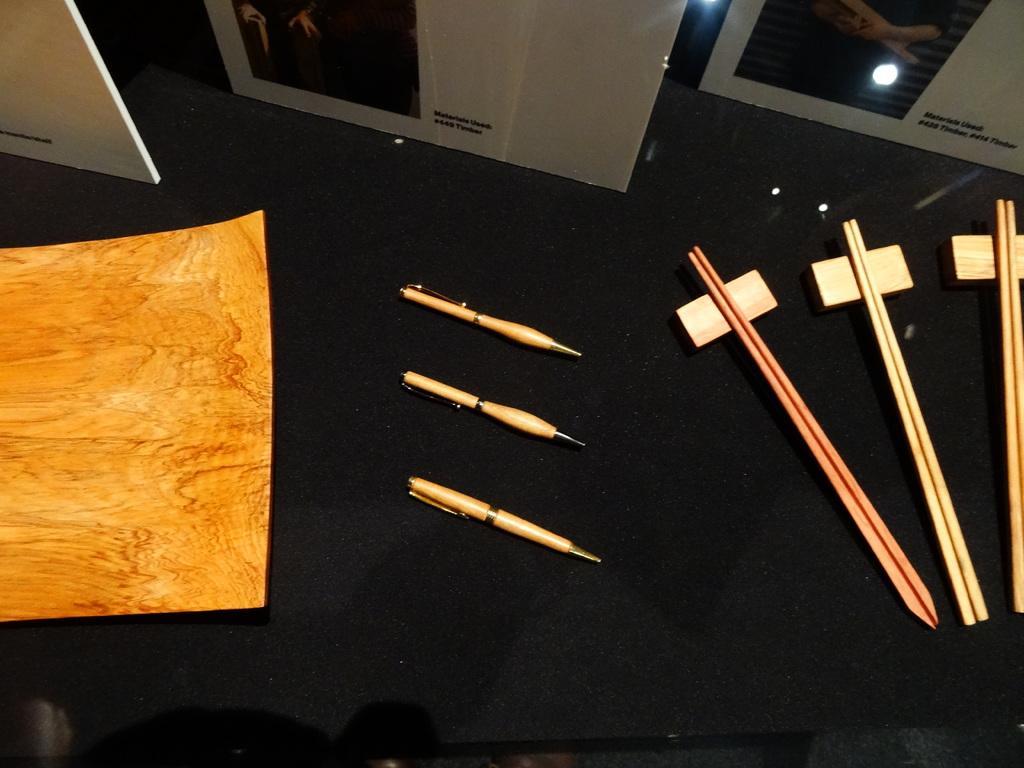Could you give a brief overview of what you see in this image? This image is clicked inside a room. There is a table or a desk in black color. On which, some pens, sticks, card boards, and posters, frames are kept. 